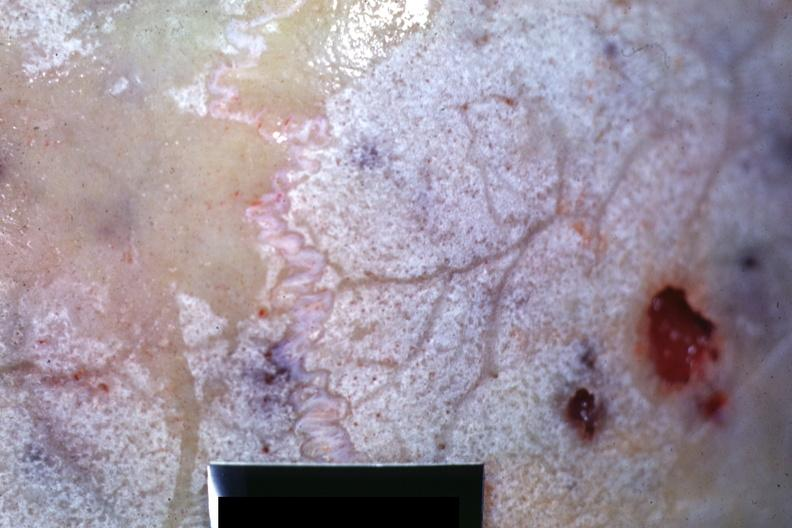what does this image show?
Answer the question using a single word or phrase. Close-up view of bone with hemorrhagic excavations 